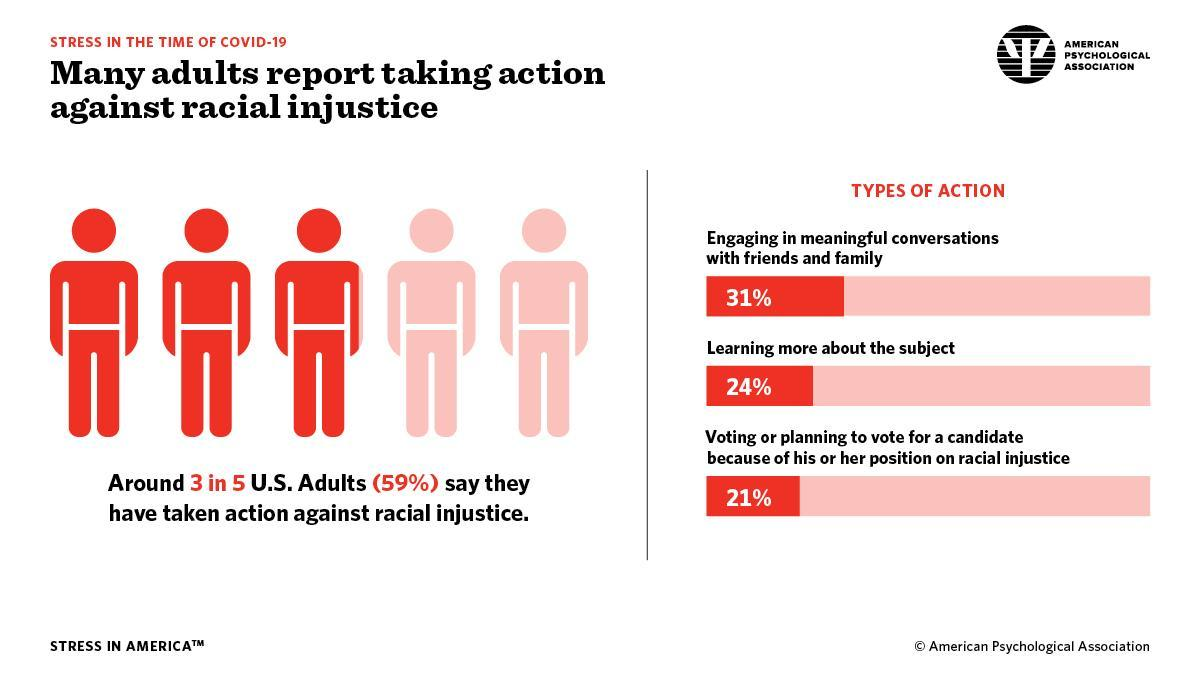What percentage of adults are not learning about the subject?
Answer the question with a short phrase. 76% What percentage of adults have not taken action against racial injustice? 41% What percentage of adults are not engaged in meaningful conversations with friends and family? 69% Out of 5,how many have not taken action against racial injustice? 2 